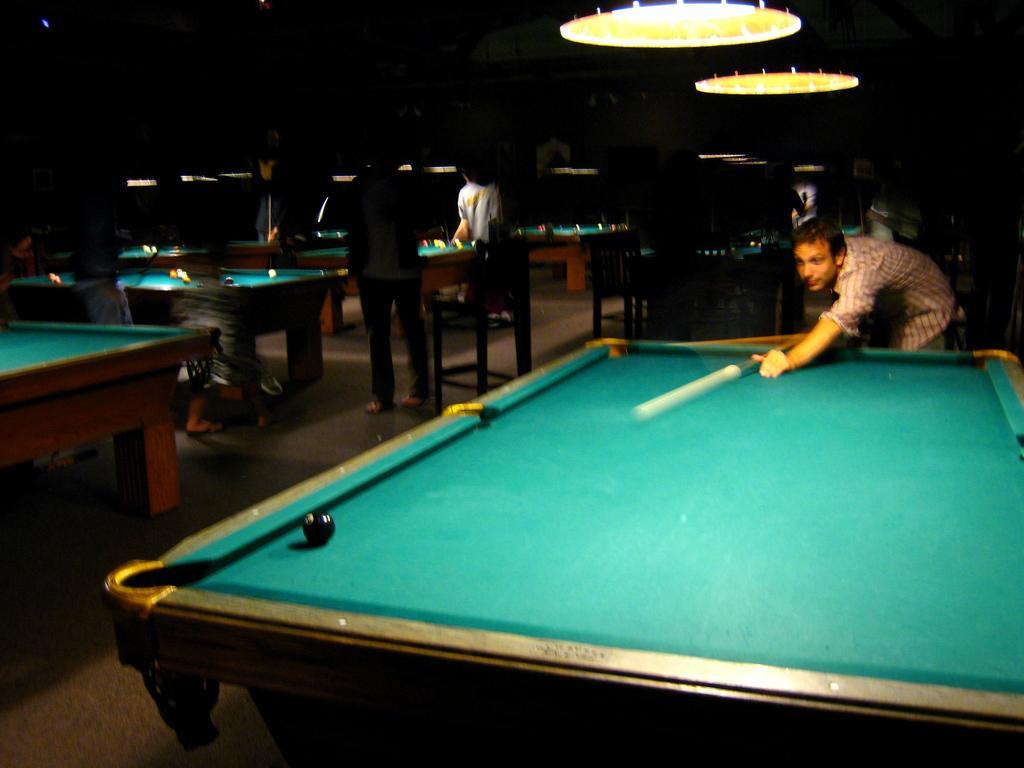In one or two sentences, can you explain what this image depicts? Here in this picture we can see number of billiard tables present on the floor and in the front we can see a person playing the game with the help of cue and we can also see a ball present on the table and we can see lights present at the top and we can see other people also standing near other table. 